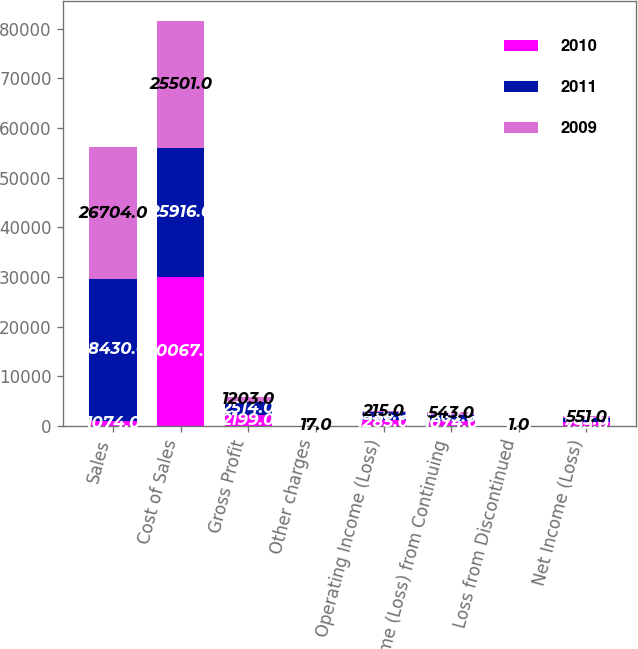Convert chart. <chart><loc_0><loc_0><loc_500><loc_500><stacked_bar_chart><ecel><fcel>Sales<fcel>Cost of Sales<fcel>Gross Profit<fcel>Other charges<fcel>Operating Income (Loss)<fcel>Income (Loss) from Continuing<fcel>Loss from Discontinued<fcel>Net Income (Loss)<nl><fcel>2010<fcel>1074<fcel>30067<fcel>2199<fcel>0<fcel>1285<fcel>1074<fcel>0<fcel>733<nl><fcel>2011<fcel>28430<fcel>25916<fcel>2514<fcel>0<fcel>1556<fcel>1203<fcel>0<fcel>765<nl><fcel>2009<fcel>26704<fcel>25501<fcel>1203<fcel>17<fcel>215<fcel>543<fcel>1<fcel>551<nl></chart> 